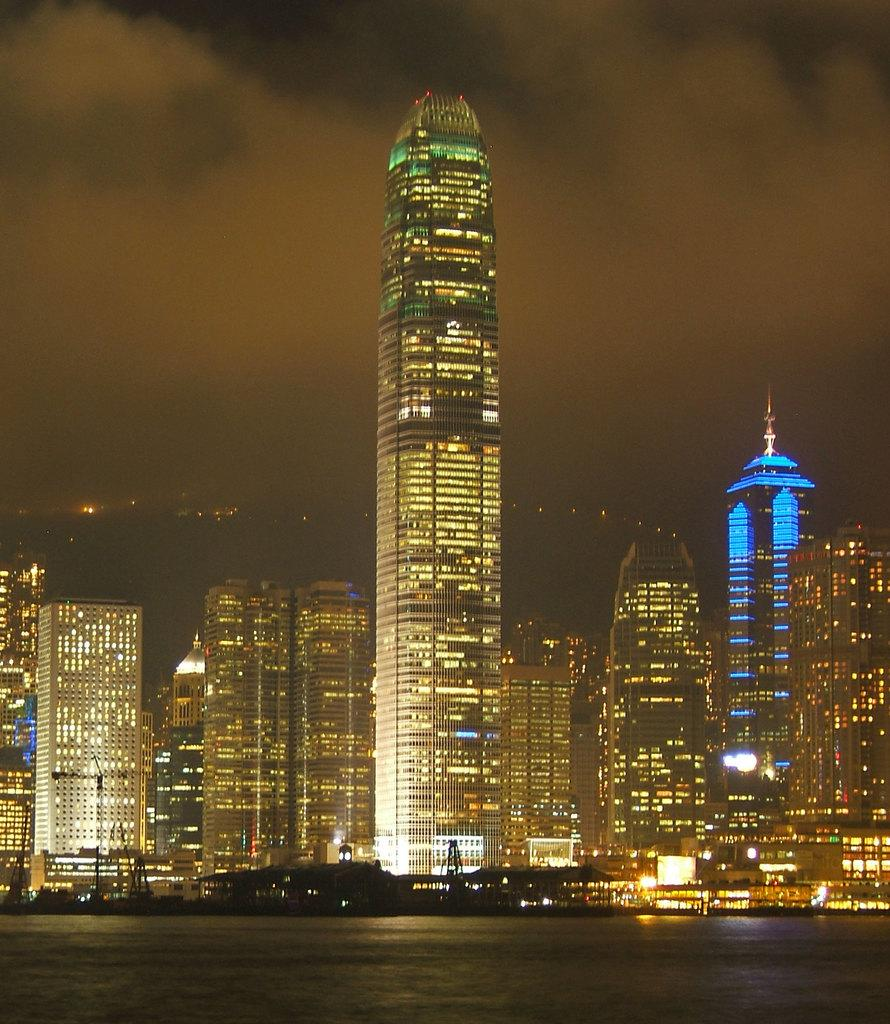What is in the foreground of the image? There is water in the foreground of the image. What type of structures can be seen in the middle of the image? There are buildings and skyscrapers in the middle of the image. How would you describe the background of the image? The background of the image is dark. What can be seen in the background besides darkness? There are lights and the sky visible in the background. What type of toy is being distributed in the image? There is no toy or distribution activity present in the image. 